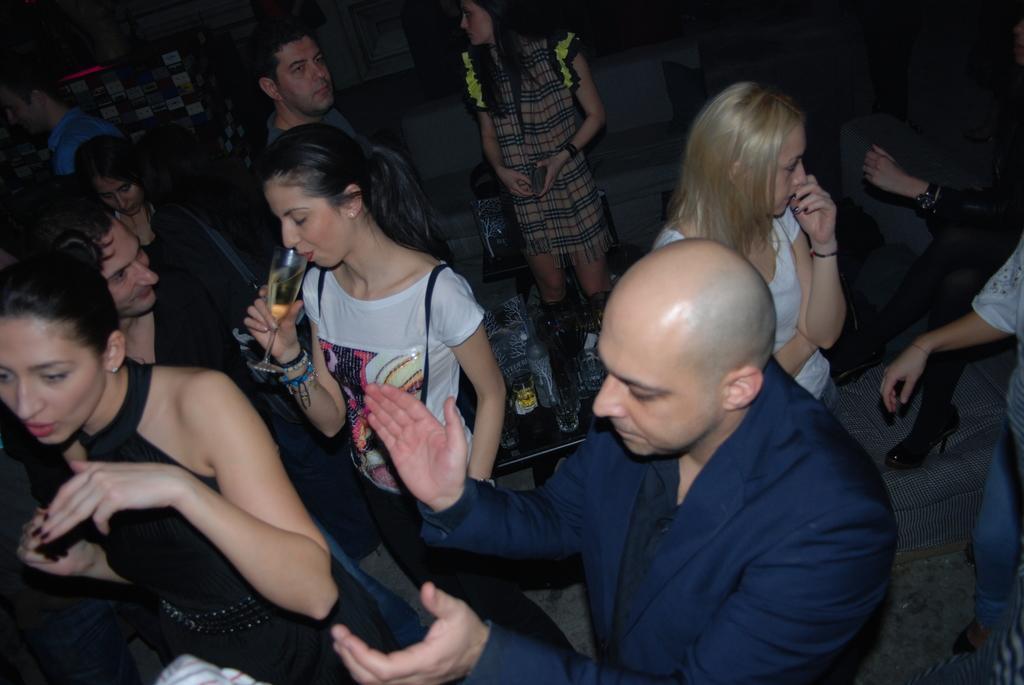Could you give a brief overview of what you see in this image? In this image I can see few people are standing and few are holding glasses. I can see few objects on the table. They are wearing different color dresses. 